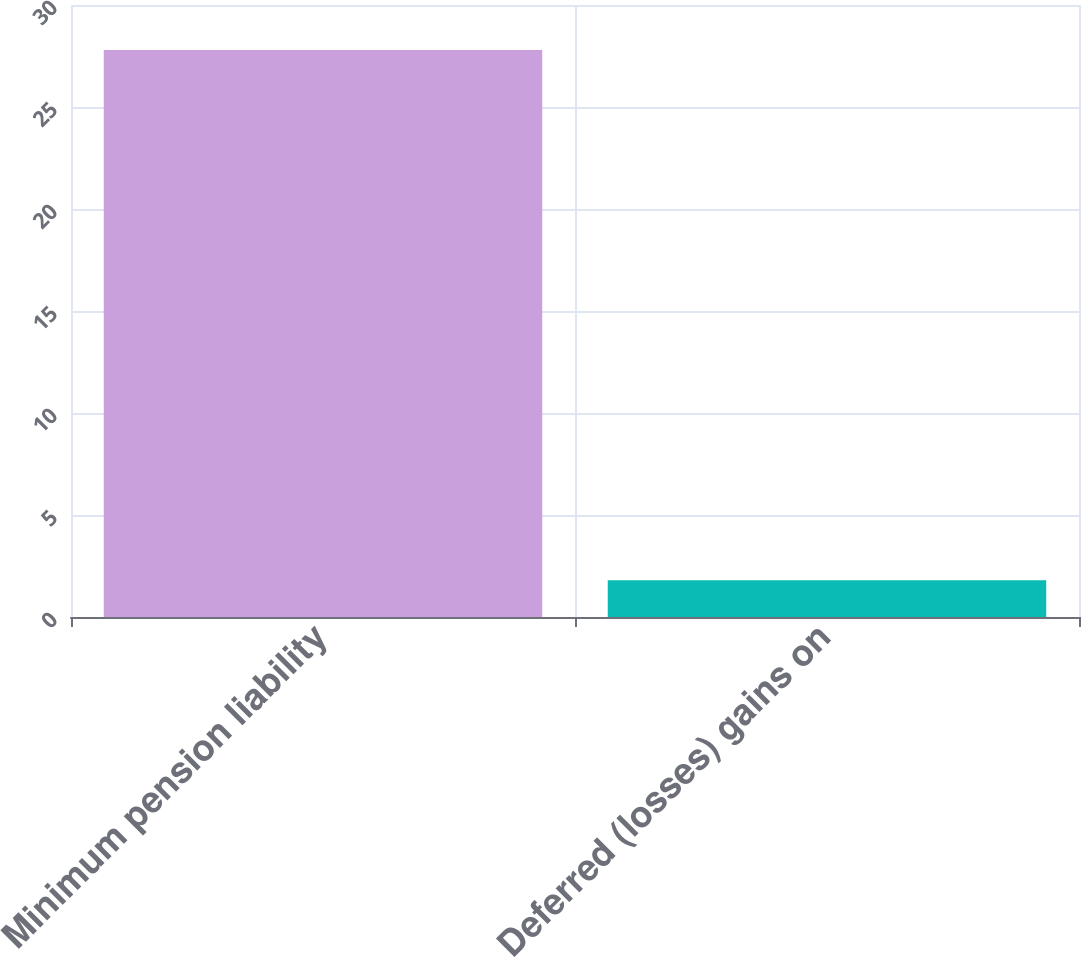Convert chart. <chart><loc_0><loc_0><loc_500><loc_500><bar_chart><fcel>Minimum pension liability<fcel>Deferred (losses) gains on<nl><fcel>27.8<fcel>1.8<nl></chart> 